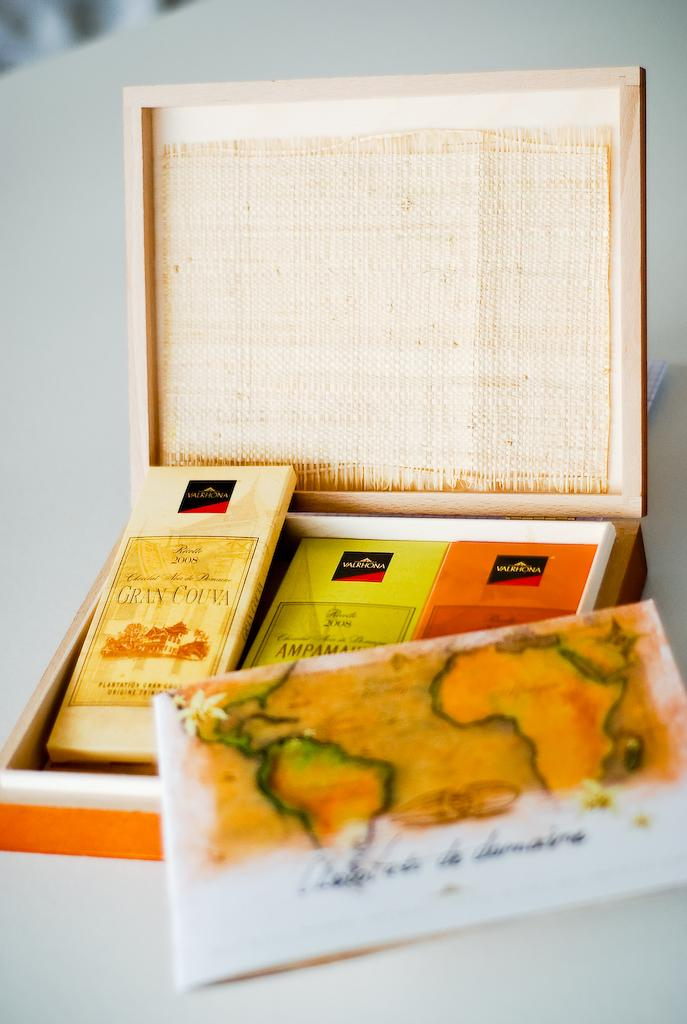What is inside the box that is visible in the image? There are objects in a box in the image. What type of written material can be seen in the image? There is a paper with text in the image. What piece of furniture is at the bottom of the image? There is a table at the bottom of the image. How many sisters are depicted in the image? There are no sisters present in the image. What type of brush is used to write the text on the paper? There is no brush visible in the image, and the method of writing the text is not specified. 